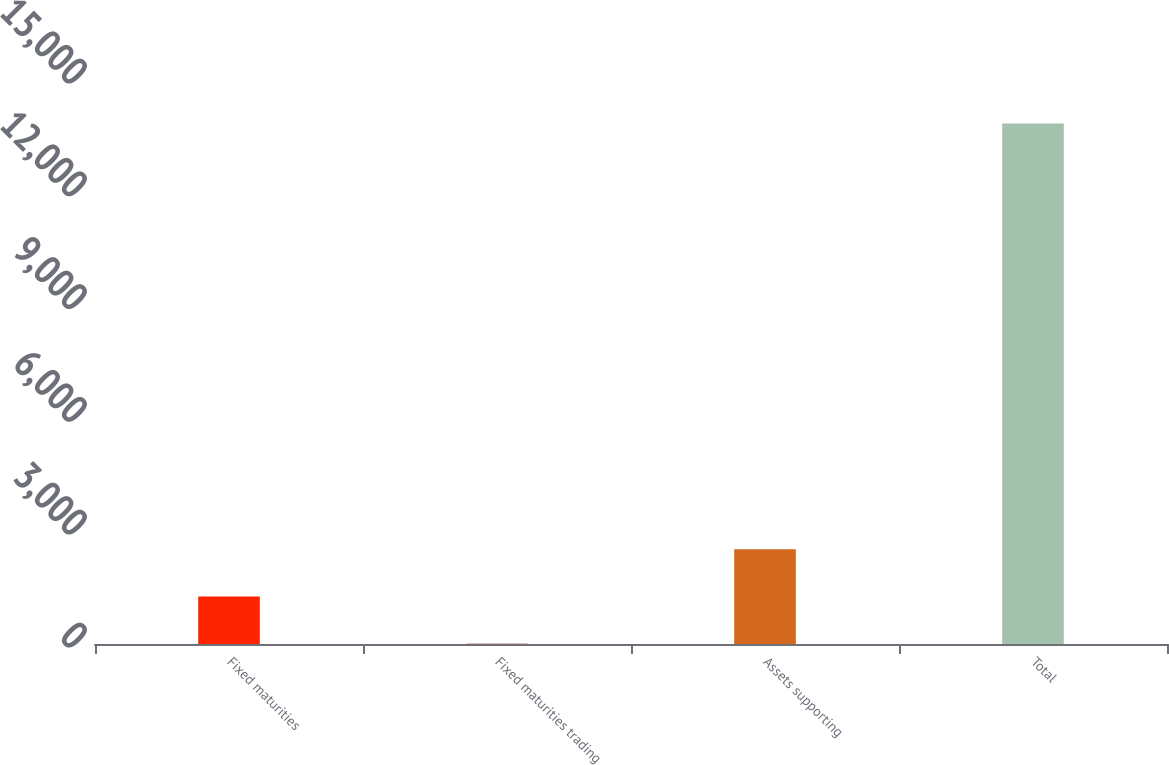Convert chart. <chart><loc_0><loc_0><loc_500><loc_500><bar_chart><fcel>Fixed maturities<fcel>Fixed maturities trading<fcel>Assets supporting<fcel>Total<nl><fcel>1263.15<fcel>3.39<fcel>2522.91<fcel>13845.8<nl></chart> 